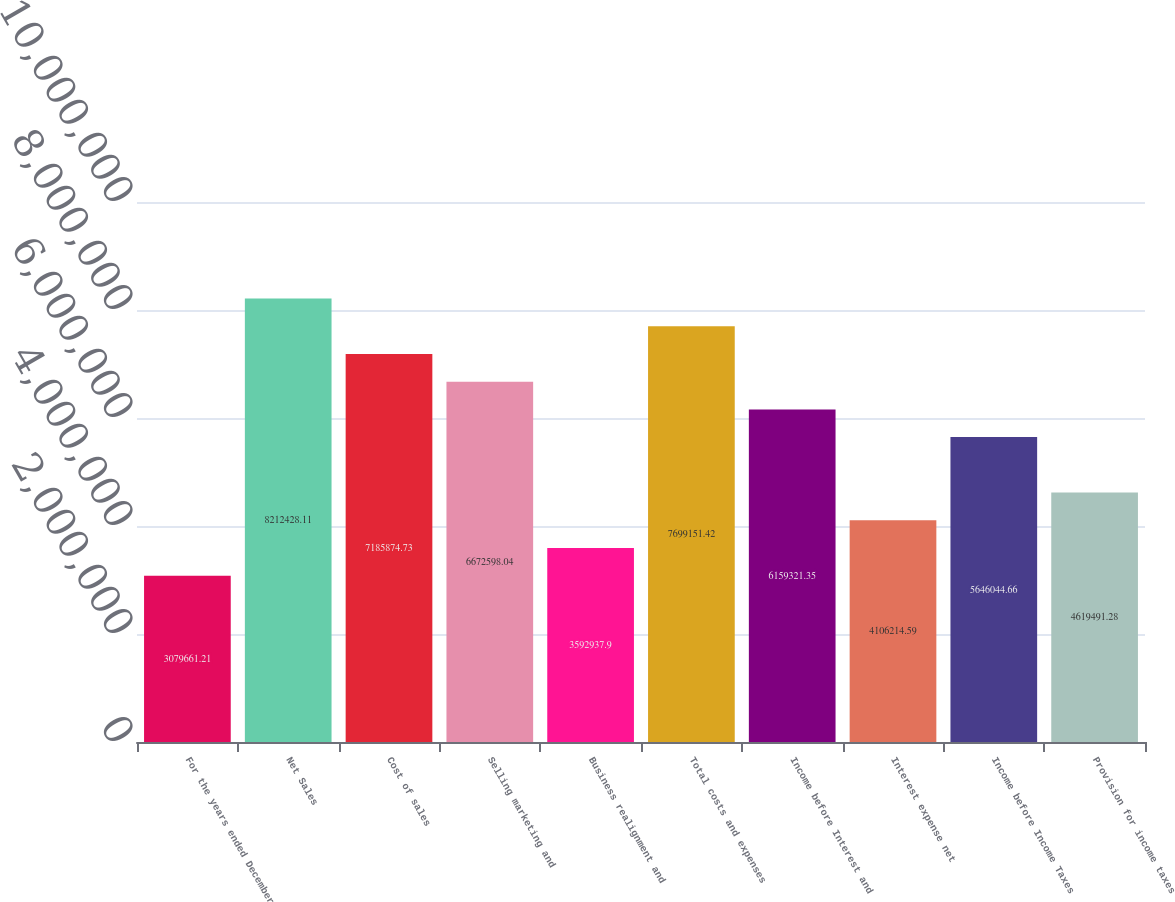Convert chart. <chart><loc_0><loc_0><loc_500><loc_500><bar_chart><fcel>For the years ended December<fcel>Net Sales<fcel>Cost of sales<fcel>Selling marketing and<fcel>Business realignment and<fcel>Total costs and expenses<fcel>Income before Interest and<fcel>Interest expense net<fcel>Income before Income Taxes<fcel>Provision for income taxes<nl><fcel>3.07966e+06<fcel>8.21243e+06<fcel>7.18587e+06<fcel>6.6726e+06<fcel>3.59294e+06<fcel>7.69915e+06<fcel>6.15932e+06<fcel>4.10621e+06<fcel>5.64604e+06<fcel>4.61949e+06<nl></chart> 